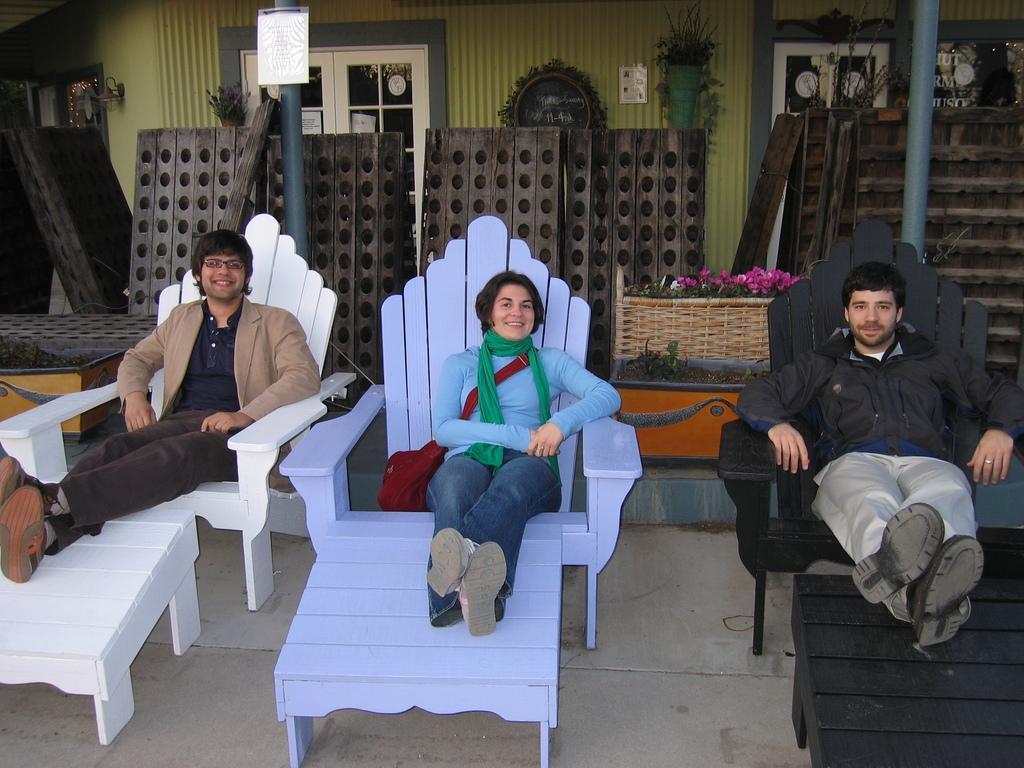How would you summarize this image in a sentence or two? In this picture we can see two men and a woman sitting on chairs and smiling and in the background we can see poles, wall, windows. 